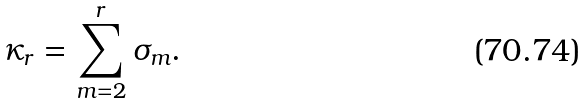<formula> <loc_0><loc_0><loc_500><loc_500>\kappa _ { r } = \sum _ { m = 2 } ^ { r } \sigma _ { m } .</formula> 